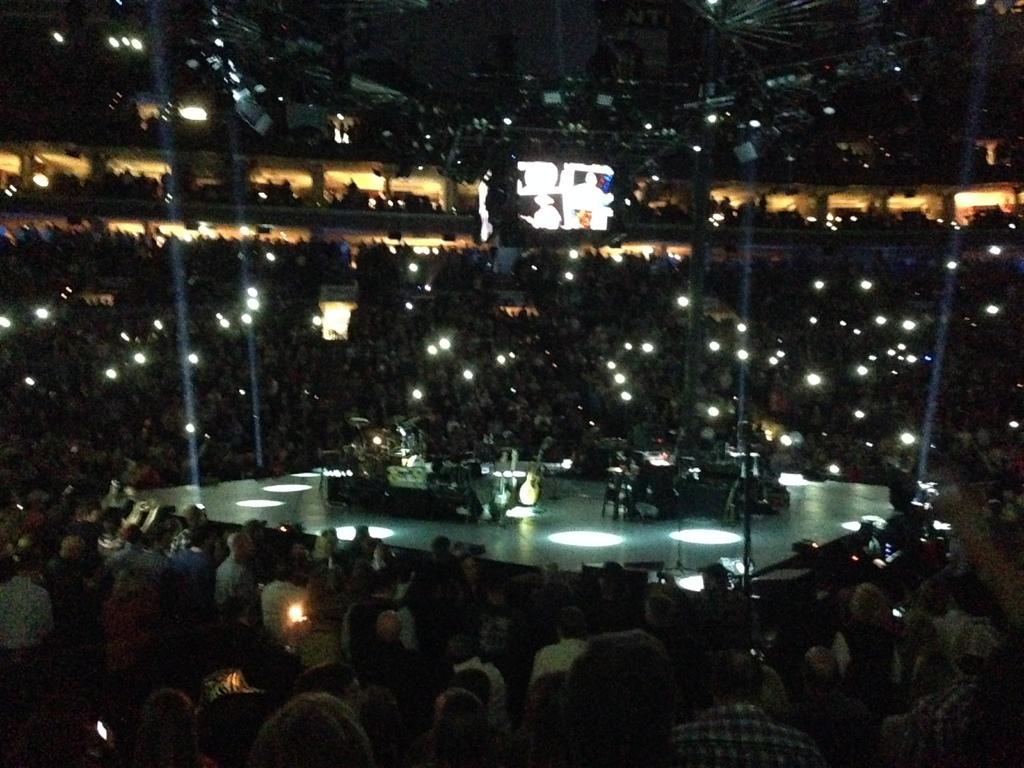What is the main feature of the image? There is a stage in the image. What is happening around the stage? There is a crowd around the stage. What can be seen on the stage? Musical instruments, such as a guitar, are present on the stage. What is visible above the crowd? There is a screen visible above the crowd. What type of coal is being used to fuel the instruments on the stage? There is no coal present in the image, and the instruments are not being fueled by coal. How many passengers are visible in the image? There is no reference to passengers in the image, so it is not possible to determine their number. 